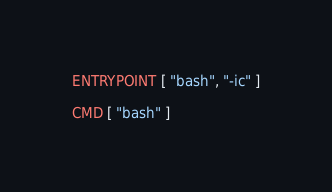<code> <loc_0><loc_0><loc_500><loc_500><_Dockerfile_>ENTRYPOINT [ "bash", "-ic" ]

CMD [ "bash" ]
</code> 